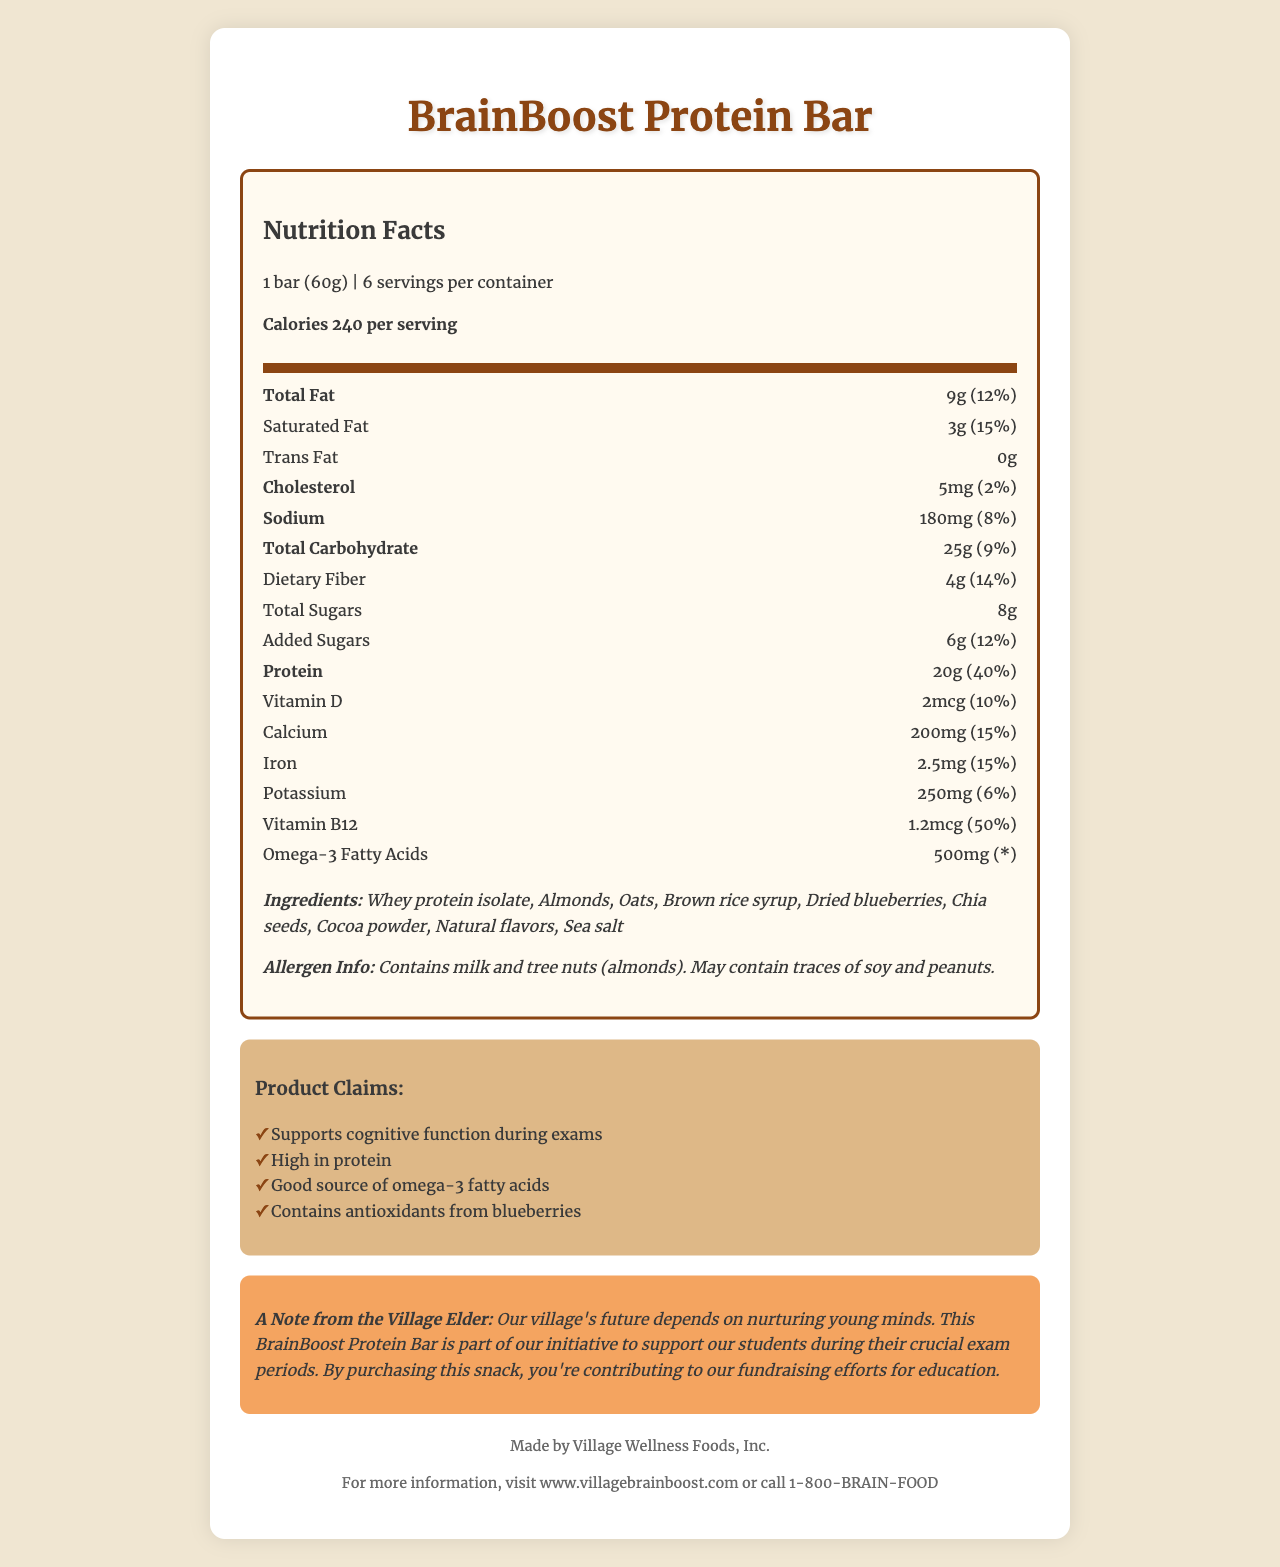what is the serving size for the BrainBoost Protein Bar? Serving size is mentioned at the top of the nutrition facts label as "1 bar (60g)."
Answer: 1 bar (60g) how many calories are in one serving of the BrainBoost Protein Bar? The document states "Calories 240 per serving" in the nutrition facts section.
Answer: 240 calories what are the main ingredients in the BrainBoost Protein Bar? The ingredients are listed under the ingredients section of the document.
Answer: Whey protein isolate, Almonds, Oats, Brown rice syrup, Dried blueberries, Chia seeds, Cocoa powder, Natural flavors, Sea salt how much protein does one serving of the bar provide? The document lists "Protein 20g" along with its percent daily value of 40%.
Answer: 20g what is the total amount of sugars in one serving, including added sugars? The nutrition label lists "Total Sugars 8g" and "Added Sugars 6g."
Answer: 8g of total sugars, 6g of added sugars which nutrient has the highest percent daily value in the BrainBoost Protein Bar? A. Vitamin D B. Calcium C. Vitamin B12 The nutrition label shows that Vitamin B12 has a 50% daily value, which is the highest compared to other nutrients listed.
Answer: C. Vitamin B12 how much dietary fiber is in each bar, and what is its percent daily value? The nutrition label shows "Dietary Fiber 4g" and "14%" in the percent daily value column.
Answer: 4g dietary fiber, 14% daily value does the BrainBoost Protein Bar contain any trans fats? The document explicitly states "Trans Fat 0g."
Answer: No how much omega-3 fatty acids does one serving contain? The amount listed for omega-3 fatty acids in the document is "500mg."
Answer: 500mg what is the total amount of fat per serving, and what is its percent daily value? The nutrition label shows "Total Fat 9g" and "12%" in the percent daily value column.
Answer: 9g of total fat, 12% daily value which of the following is not listed as a claim on the BrainBoost Protein Bar? A. Supports cognitive function during exams B. Good source of omega-3 fatty acids C. Low in carbohydrates D. Contains antioxidants from blueberries The nutrition label and claim statements list options A, B, and D but do not mention anything about being low in carbohydrates.
Answer: C. Low in carbohydrates does the BrainBoost Protein Bar contain any allergens? The allergen info section notes that the bar "Contains milk and tree nuts (almonds)” and may contain traces of soy and peanuts.
Answer: Yes does the BrainBoost Protein Bar support cognitive function during exams? One of the claim statements in the document is "Supports cognitive function during exams."
Answer: Yes can it be determined if the BrainBoost Protein Bar is gluten-free from this document? The document does not provide information explicitly stating whether the bar is gluten-free.
Answer: Cannot be determined what could be a brief summary of the BrainBoost Protein Bar document? The document outlines its nutritional values, ingredients, allergen information, and health claims, emphasizing its support for cognitive function and educational fundraising.
Answer: The BrainBoost Protein Bar is a high-protein snack designed to support students during exams with various nutritional benefits and specific ingredient information. who is the manufacturer of the BrainBoost Protein Bar? The manufacturer info section at the bottom of the document states "Made by Village Wellness Foods, Inc."
Answer: Village Wellness Foods, Inc. 